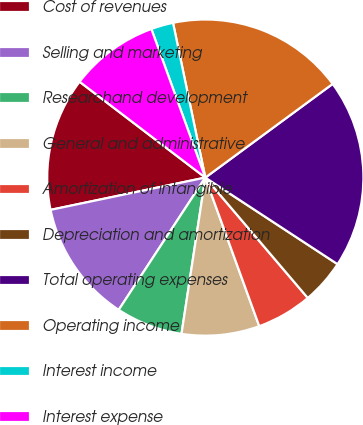Convert chart to OTSL. <chart><loc_0><loc_0><loc_500><loc_500><pie_chart><fcel>Cost of revenues<fcel>Selling and marketing<fcel>Researchand development<fcel>General and administrative<fcel>Amortization of intangible<fcel>Depreciation and amortization<fcel>Total operating expenses<fcel>Operating income<fcel>Interest income<fcel>Interest expense<nl><fcel>13.64%<fcel>12.5%<fcel>6.82%<fcel>7.95%<fcel>5.68%<fcel>4.55%<fcel>19.32%<fcel>18.18%<fcel>2.27%<fcel>9.09%<nl></chart> 